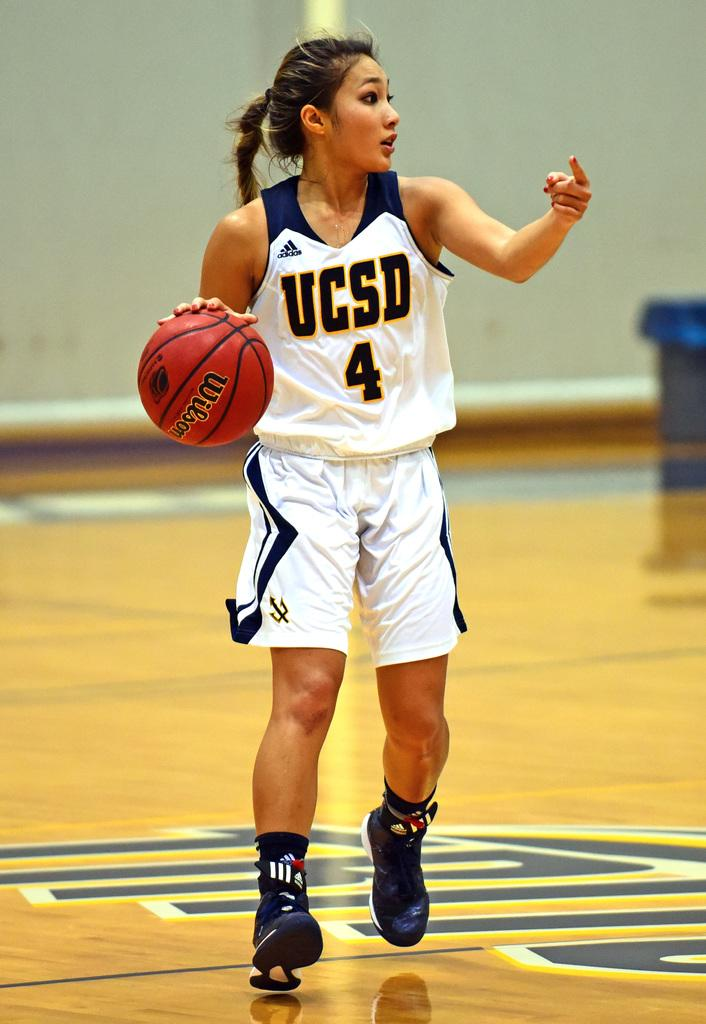<image>
Present a compact description of the photo's key features. A female UCSD basketball player dribbles the ball. 